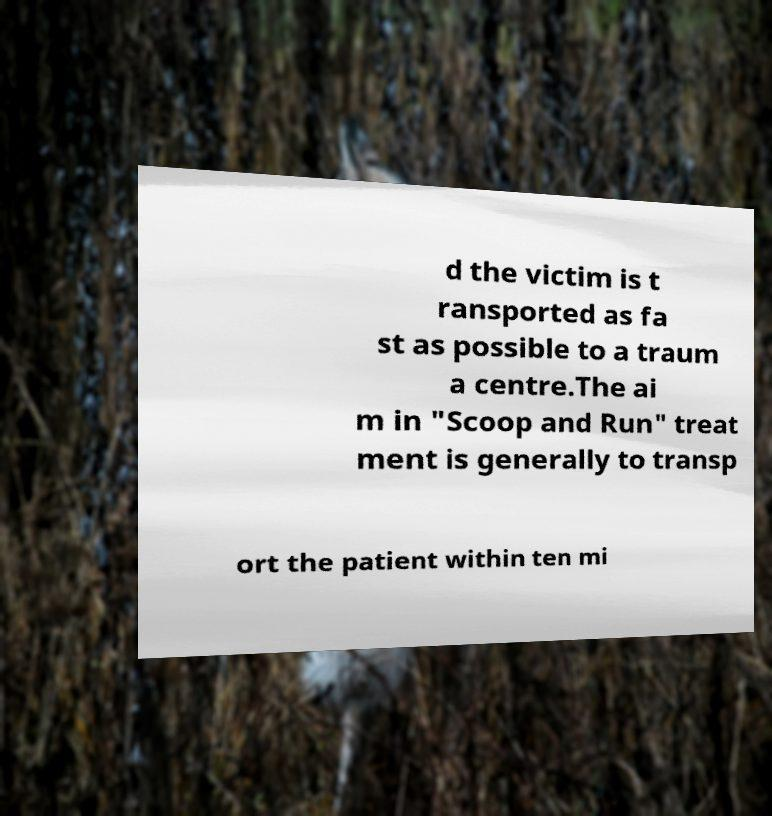Could you assist in decoding the text presented in this image and type it out clearly? d the victim is t ransported as fa st as possible to a traum a centre.The ai m in "Scoop and Run" treat ment is generally to transp ort the patient within ten mi 